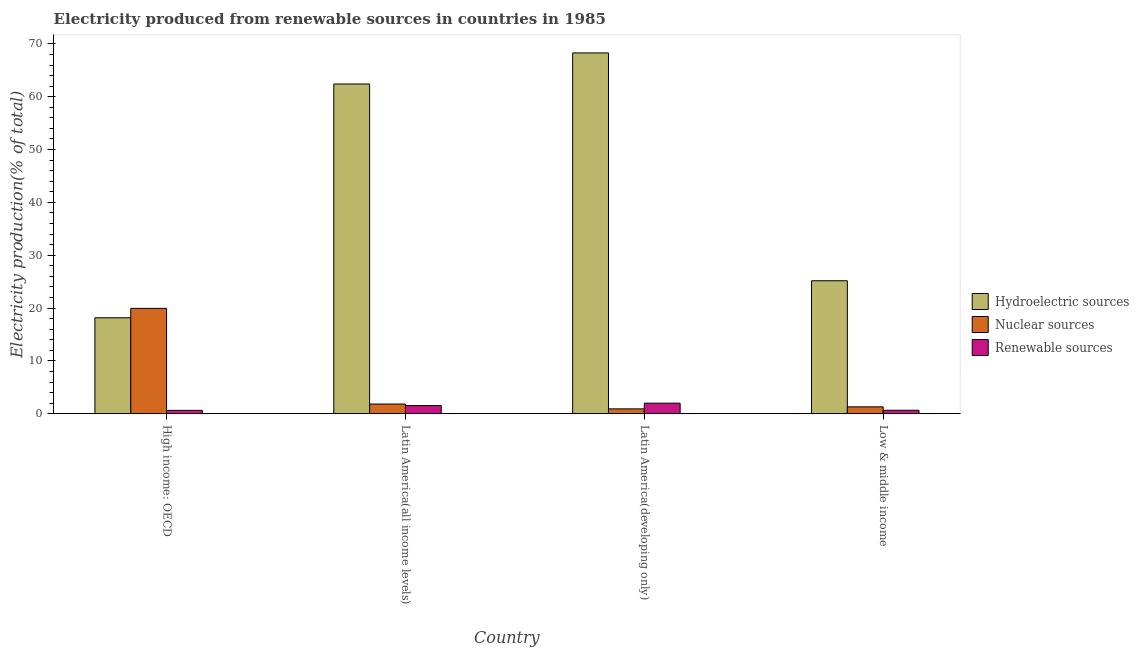How many different coloured bars are there?
Offer a terse response. 3. Are the number of bars per tick equal to the number of legend labels?
Your response must be concise. Yes. How many bars are there on the 2nd tick from the right?
Ensure brevity in your answer.  3. What is the percentage of electricity produced by hydroelectric sources in Low & middle income?
Provide a succinct answer. 25.17. Across all countries, what is the maximum percentage of electricity produced by nuclear sources?
Offer a very short reply. 19.94. Across all countries, what is the minimum percentage of electricity produced by hydroelectric sources?
Your answer should be very brief. 18.17. In which country was the percentage of electricity produced by hydroelectric sources maximum?
Your response must be concise. Latin America(developing only). In which country was the percentage of electricity produced by renewable sources minimum?
Provide a short and direct response. High income: OECD. What is the total percentage of electricity produced by hydroelectric sources in the graph?
Your response must be concise. 174.03. What is the difference between the percentage of electricity produced by hydroelectric sources in High income: OECD and that in Low & middle income?
Make the answer very short. -7. What is the difference between the percentage of electricity produced by hydroelectric sources in High income: OECD and the percentage of electricity produced by nuclear sources in Low & middle income?
Make the answer very short. 16.86. What is the average percentage of electricity produced by hydroelectric sources per country?
Offer a very short reply. 43.51. What is the difference between the percentage of electricity produced by hydroelectric sources and percentage of electricity produced by nuclear sources in Low & middle income?
Your answer should be compact. 23.86. In how many countries, is the percentage of electricity produced by hydroelectric sources greater than 42 %?
Provide a succinct answer. 2. What is the ratio of the percentage of electricity produced by nuclear sources in High income: OECD to that in Low & middle income?
Offer a very short reply. 15.3. Is the percentage of electricity produced by renewable sources in Latin America(developing only) less than that in Low & middle income?
Make the answer very short. No. Is the difference between the percentage of electricity produced by nuclear sources in High income: OECD and Latin America(developing only) greater than the difference between the percentage of electricity produced by hydroelectric sources in High income: OECD and Latin America(developing only)?
Provide a short and direct response. Yes. What is the difference between the highest and the second highest percentage of electricity produced by nuclear sources?
Give a very brief answer. 18.11. What is the difference between the highest and the lowest percentage of electricity produced by nuclear sources?
Provide a succinct answer. 19.02. What does the 2nd bar from the left in Latin America(all income levels) represents?
Your answer should be very brief. Nuclear sources. What does the 1st bar from the right in High income: OECD represents?
Provide a succinct answer. Renewable sources. Is it the case that in every country, the sum of the percentage of electricity produced by hydroelectric sources and percentage of electricity produced by nuclear sources is greater than the percentage of electricity produced by renewable sources?
Offer a very short reply. Yes. How many bars are there?
Provide a short and direct response. 12. Are all the bars in the graph horizontal?
Provide a succinct answer. No. How many countries are there in the graph?
Make the answer very short. 4. Does the graph contain any zero values?
Provide a succinct answer. No. Does the graph contain grids?
Your response must be concise. No. Where does the legend appear in the graph?
Your response must be concise. Center right. How many legend labels are there?
Provide a succinct answer. 3. What is the title of the graph?
Offer a very short reply. Electricity produced from renewable sources in countries in 1985. What is the label or title of the Y-axis?
Make the answer very short. Electricity production(% of total). What is the Electricity production(% of total) of Hydroelectric sources in High income: OECD?
Keep it short and to the point. 18.17. What is the Electricity production(% of total) in Nuclear sources in High income: OECD?
Keep it short and to the point. 19.94. What is the Electricity production(% of total) in Renewable sources in High income: OECD?
Provide a succinct answer. 0.64. What is the Electricity production(% of total) in Hydroelectric sources in Latin America(all income levels)?
Provide a short and direct response. 62.41. What is the Electricity production(% of total) of Nuclear sources in Latin America(all income levels)?
Your answer should be compact. 1.83. What is the Electricity production(% of total) of Renewable sources in Latin America(all income levels)?
Your answer should be very brief. 1.54. What is the Electricity production(% of total) in Hydroelectric sources in Latin America(developing only)?
Your answer should be compact. 68.29. What is the Electricity production(% of total) of Nuclear sources in Latin America(developing only)?
Offer a very short reply. 0.92. What is the Electricity production(% of total) in Renewable sources in Latin America(developing only)?
Provide a succinct answer. 2. What is the Electricity production(% of total) in Hydroelectric sources in Low & middle income?
Your response must be concise. 25.17. What is the Electricity production(% of total) of Nuclear sources in Low & middle income?
Your answer should be compact. 1.3. What is the Electricity production(% of total) of Renewable sources in Low & middle income?
Keep it short and to the point. 0.66. Across all countries, what is the maximum Electricity production(% of total) of Hydroelectric sources?
Offer a terse response. 68.29. Across all countries, what is the maximum Electricity production(% of total) in Nuclear sources?
Provide a short and direct response. 19.94. Across all countries, what is the maximum Electricity production(% of total) in Renewable sources?
Keep it short and to the point. 2. Across all countries, what is the minimum Electricity production(% of total) of Hydroelectric sources?
Keep it short and to the point. 18.17. Across all countries, what is the minimum Electricity production(% of total) in Nuclear sources?
Your answer should be very brief. 0.92. Across all countries, what is the minimum Electricity production(% of total) of Renewable sources?
Give a very brief answer. 0.64. What is the total Electricity production(% of total) in Hydroelectric sources in the graph?
Offer a terse response. 174.03. What is the total Electricity production(% of total) in Nuclear sources in the graph?
Provide a short and direct response. 24. What is the total Electricity production(% of total) in Renewable sources in the graph?
Give a very brief answer. 4.84. What is the difference between the Electricity production(% of total) in Hydroelectric sources in High income: OECD and that in Latin America(all income levels)?
Your answer should be compact. -44.24. What is the difference between the Electricity production(% of total) in Nuclear sources in High income: OECD and that in Latin America(all income levels)?
Your answer should be compact. 18.11. What is the difference between the Electricity production(% of total) in Renewable sources in High income: OECD and that in Latin America(all income levels)?
Keep it short and to the point. -0.9. What is the difference between the Electricity production(% of total) of Hydroelectric sources in High income: OECD and that in Latin America(developing only)?
Provide a succinct answer. -50.12. What is the difference between the Electricity production(% of total) of Nuclear sources in High income: OECD and that in Latin America(developing only)?
Give a very brief answer. 19.02. What is the difference between the Electricity production(% of total) of Renewable sources in High income: OECD and that in Latin America(developing only)?
Keep it short and to the point. -1.36. What is the difference between the Electricity production(% of total) in Hydroelectric sources in High income: OECD and that in Low & middle income?
Offer a very short reply. -7. What is the difference between the Electricity production(% of total) in Nuclear sources in High income: OECD and that in Low & middle income?
Offer a terse response. 18.64. What is the difference between the Electricity production(% of total) in Renewable sources in High income: OECD and that in Low & middle income?
Ensure brevity in your answer.  -0.02. What is the difference between the Electricity production(% of total) in Hydroelectric sources in Latin America(all income levels) and that in Latin America(developing only)?
Provide a succinct answer. -5.88. What is the difference between the Electricity production(% of total) in Nuclear sources in Latin America(all income levels) and that in Latin America(developing only)?
Offer a very short reply. 0.91. What is the difference between the Electricity production(% of total) in Renewable sources in Latin America(all income levels) and that in Latin America(developing only)?
Keep it short and to the point. -0.46. What is the difference between the Electricity production(% of total) in Hydroelectric sources in Latin America(all income levels) and that in Low & middle income?
Give a very brief answer. 37.24. What is the difference between the Electricity production(% of total) in Nuclear sources in Latin America(all income levels) and that in Low & middle income?
Provide a short and direct response. 0.53. What is the difference between the Electricity production(% of total) in Renewable sources in Latin America(all income levels) and that in Low & middle income?
Offer a very short reply. 0.88. What is the difference between the Electricity production(% of total) in Hydroelectric sources in Latin America(developing only) and that in Low & middle income?
Offer a very short reply. 43.12. What is the difference between the Electricity production(% of total) of Nuclear sources in Latin America(developing only) and that in Low & middle income?
Offer a very short reply. -0.38. What is the difference between the Electricity production(% of total) of Renewable sources in Latin America(developing only) and that in Low & middle income?
Make the answer very short. 1.34. What is the difference between the Electricity production(% of total) in Hydroelectric sources in High income: OECD and the Electricity production(% of total) in Nuclear sources in Latin America(all income levels)?
Provide a short and direct response. 16.33. What is the difference between the Electricity production(% of total) in Hydroelectric sources in High income: OECD and the Electricity production(% of total) in Renewable sources in Latin America(all income levels)?
Ensure brevity in your answer.  16.62. What is the difference between the Electricity production(% of total) of Nuclear sources in High income: OECD and the Electricity production(% of total) of Renewable sources in Latin America(all income levels)?
Provide a succinct answer. 18.4. What is the difference between the Electricity production(% of total) in Hydroelectric sources in High income: OECD and the Electricity production(% of total) in Nuclear sources in Latin America(developing only)?
Make the answer very short. 17.24. What is the difference between the Electricity production(% of total) in Hydroelectric sources in High income: OECD and the Electricity production(% of total) in Renewable sources in Latin America(developing only)?
Provide a short and direct response. 16.17. What is the difference between the Electricity production(% of total) in Nuclear sources in High income: OECD and the Electricity production(% of total) in Renewable sources in Latin America(developing only)?
Your answer should be compact. 17.94. What is the difference between the Electricity production(% of total) of Hydroelectric sources in High income: OECD and the Electricity production(% of total) of Nuclear sources in Low & middle income?
Your response must be concise. 16.86. What is the difference between the Electricity production(% of total) in Hydroelectric sources in High income: OECD and the Electricity production(% of total) in Renewable sources in Low & middle income?
Your answer should be compact. 17.51. What is the difference between the Electricity production(% of total) of Nuclear sources in High income: OECD and the Electricity production(% of total) of Renewable sources in Low & middle income?
Your answer should be very brief. 19.28. What is the difference between the Electricity production(% of total) in Hydroelectric sources in Latin America(all income levels) and the Electricity production(% of total) in Nuclear sources in Latin America(developing only)?
Your answer should be very brief. 61.49. What is the difference between the Electricity production(% of total) of Hydroelectric sources in Latin America(all income levels) and the Electricity production(% of total) of Renewable sources in Latin America(developing only)?
Offer a very short reply. 60.41. What is the difference between the Electricity production(% of total) of Nuclear sources in Latin America(all income levels) and the Electricity production(% of total) of Renewable sources in Latin America(developing only)?
Your answer should be compact. -0.17. What is the difference between the Electricity production(% of total) in Hydroelectric sources in Latin America(all income levels) and the Electricity production(% of total) in Nuclear sources in Low & middle income?
Offer a very short reply. 61.11. What is the difference between the Electricity production(% of total) in Hydroelectric sources in Latin America(all income levels) and the Electricity production(% of total) in Renewable sources in Low & middle income?
Your answer should be compact. 61.75. What is the difference between the Electricity production(% of total) in Nuclear sources in Latin America(all income levels) and the Electricity production(% of total) in Renewable sources in Low & middle income?
Offer a terse response. 1.17. What is the difference between the Electricity production(% of total) of Hydroelectric sources in Latin America(developing only) and the Electricity production(% of total) of Nuclear sources in Low & middle income?
Provide a short and direct response. 66.98. What is the difference between the Electricity production(% of total) in Hydroelectric sources in Latin America(developing only) and the Electricity production(% of total) in Renewable sources in Low & middle income?
Your response must be concise. 67.63. What is the difference between the Electricity production(% of total) of Nuclear sources in Latin America(developing only) and the Electricity production(% of total) of Renewable sources in Low & middle income?
Your response must be concise. 0.26. What is the average Electricity production(% of total) of Hydroelectric sources per country?
Give a very brief answer. 43.51. What is the average Electricity production(% of total) in Nuclear sources per country?
Your response must be concise. 6. What is the average Electricity production(% of total) in Renewable sources per country?
Offer a very short reply. 1.21. What is the difference between the Electricity production(% of total) in Hydroelectric sources and Electricity production(% of total) in Nuclear sources in High income: OECD?
Provide a short and direct response. -1.78. What is the difference between the Electricity production(% of total) in Hydroelectric sources and Electricity production(% of total) in Renewable sources in High income: OECD?
Make the answer very short. 17.53. What is the difference between the Electricity production(% of total) in Nuclear sources and Electricity production(% of total) in Renewable sources in High income: OECD?
Your answer should be very brief. 19.3. What is the difference between the Electricity production(% of total) in Hydroelectric sources and Electricity production(% of total) in Nuclear sources in Latin America(all income levels)?
Keep it short and to the point. 60.58. What is the difference between the Electricity production(% of total) of Hydroelectric sources and Electricity production(% of total) of Renewable sources in Latin America(all income levels)?
Your answer should be compact. 60.87. What is the difference between the Electricity production(% of total) of Nuclear sources and Electricity production(% of total) of Renewable sources in Latin America(all income levels)?
Make the answer very short. 0.29. What is the difference between the Electricity production(% of total) in Hydroelectric sources and Electricity production(% of total) in Nuclear sources in Latin America(developing only)?
Your answer should be compact. 67.37. What is the difference between the Electricity production(% of total) in Hydroelectric sources and Electricity production(% of total) in Renewable sources in Latin America(developing only)?
Give a very brief answer. 66.29. What is the difference between the Electricity production(% of total) of Nuclear sources and Electricity production(% of total) of Renewable sources in Latin America(developing only)?
Offer a terse response. -1.08. What is the difference between the Electricity production(% of total) of Hydroelectric sources and Electricity production(% of total) of Nuclear sources in Low & middle income?
Ensure brevity in your answer.  23.86. What is the difference between the Electricity production(% of total) in Hydroelectric sources and Electricity production(% of total) in Renewable sources in Low & middle income?
Keep it short and to the point. 24.51. What is the difference between the Electricity production(% of total) in Nuclear sources and Electricity production(% of total) in Renewable sources in Low & middle income?
Ensure brevity in your answer.  0.64. What is the ratio of the Electricity production(% of total) of Hydroelectric sources in High income: OECD to that in Latin America(all income levels)?
Offer a terse response. 0.29. What is the ratio of the Electricity production(% of total) in Nuclear sources in High income: OECD to that in Latin America(all income levels)?
Keep it short and to the point. 10.87. What is the ratio of the Electricity production(% of total) in Renewable sources in High income: OECD to that in Latin America(all income levels)?
Offer a terse response. 0.41. What is the ratio of the Electricity production(% of total) of Hydroelectric sources in High income: OECD to that in Latin America(developing only)?
Your answer should be very brief. 0.27. What is the ratio of the Electricity production(% of total) in Nuclear sources in High income: OECD to that in Latin America(developing only)?
Ensure brevity in your answer.  21.62. What is the ratio of the Electricity production(% of total) in Renewable sources in High income: OECD to that in Latin America(developing only)?
Provide a succinct answer. 0.32. What is the ratio of the Electricity production(% of total) of Hydroelectric sources in High income: OECD to that in Low & middle income?
Your answer should be very brief. 0.72. What is the ratio of the Electricity production(% of total) in Nuclear sources in High income: OECD to that in Low & middle income?
Give a very brief answer. 15.3. What is the ratio of the Electricity production(% of total) in Renewable sources in High income: OECD to that in Low & middle income?
Ensure brevity in your answer.  0.97. What is the ratio of the Electricity production(% of total) of Hydroelectric sources in Latin America(all income levels) to that in Latin America(developing only)?
Keep it short and to the point. 0.91. What is the ratio of the Electricity production(% of total) of Nuclear sources in Latin America(all income levels) to that in Latin America(developing only)?
Provide a short and direct response. 1.99. What is the ratio of the Electricity production(% of total) in Renewable sources in Latin America(all income levels) to that in Latin America(developing only)?
Ensure brevity in your answer.  0.77. What is the ratio of the Electricity production(% of total) of Hydroelectric sources in Latin America(all income levels) to that in Low & middle income?
Provide a short and direct response. 2.48. What is the ratio of the Electricity production(% of total) of Nuclear sources in Latin America(all income levels) to that in Low & middle income?
Provide a succinct answer. 1.41. What is the ratio of the Electricity production(% of total) in Renewable sources in Latin America(all income levels) to that in Low & middle income?
Give a very brief answer. 2.34. What is the ratio of the Electricity production(% of total) in Hydroelectric sources in Latin America(developing only) to that in Low & middle income?
Offer a very short reply. 2.71. What is the ratio of the Electricity production(% of total) in Nuclear sources in Latin America(developing only) to that in Low & middle income?
Your answer should be very brief. 0.71. What is the ratio of the Electricity production(% of total) of Renewable sources in Latin America(developing only) to that in Low & middle income?
Offer a very short reply. 3.03. What is the difference between the highest and the second highest Electricity production(% of total) of Hydroelectric sources?
Your answer should be compact. 5.88. What is the difference between the highest and the second highest Electricity production(% of total) in Nuclear sources?
Make the answer very short. 18.11. What is the difference between the highest and the second highest Electricity production(% of total) of Renewable sources?
Provide a succinct answer. 0.46. What is the difference between the highest and the lowest Electricity production(% of total) of Hydroelectric sources?
Your answer should be compact. 50.12. What is the difference between the highest and the lowest Electricity production(% of total) of Nuclear sources?
Offer a terse response. 19.02. What is the difference between the highest and the lowest Electricity production(% of total) of Renewable sources?
Provide a succinct answer. 1.36. 